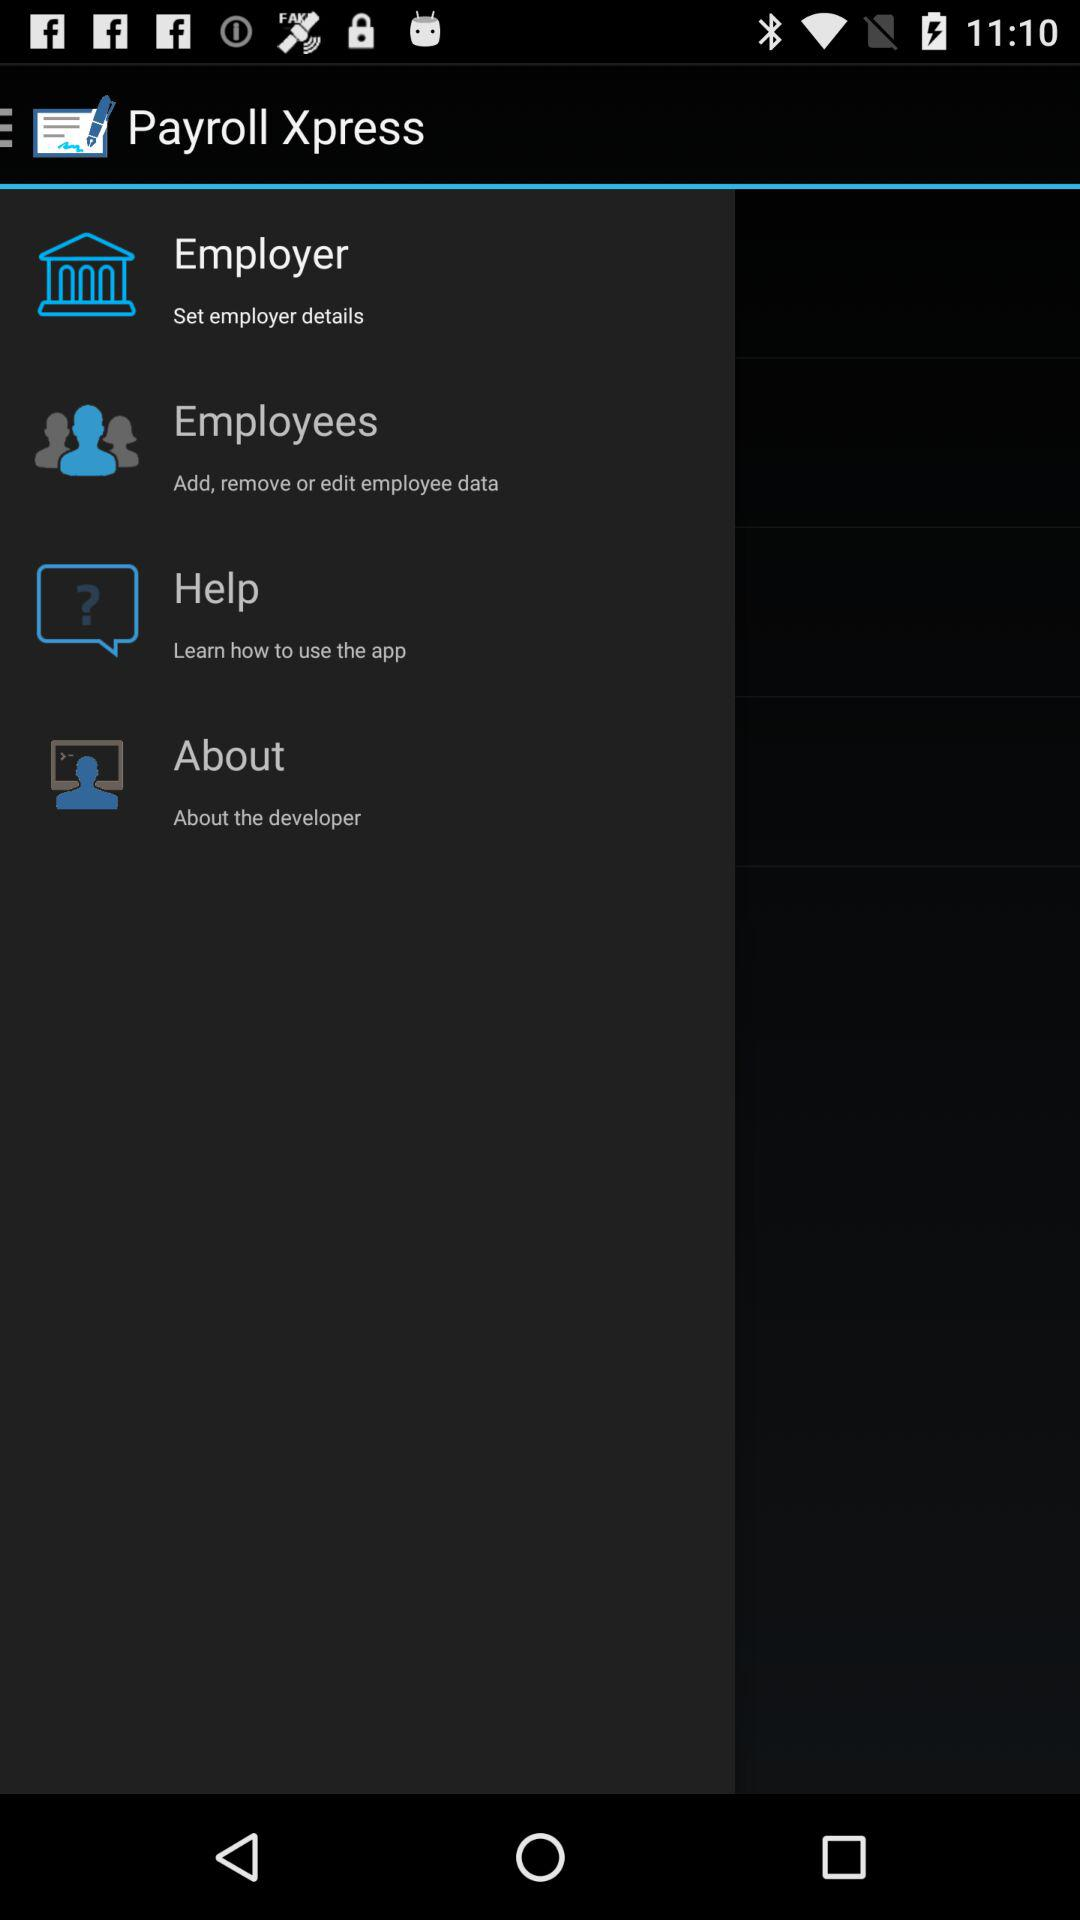What is the application name? The application name is "Payroll Xpress". 